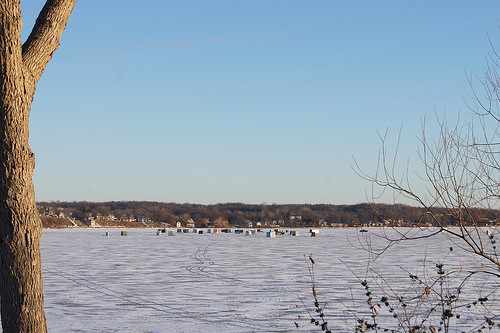<image>
Is there a tree in front of the lake? Yes. The tree is positioned in front of the lake, appearing closer to the camera viewpoint. 